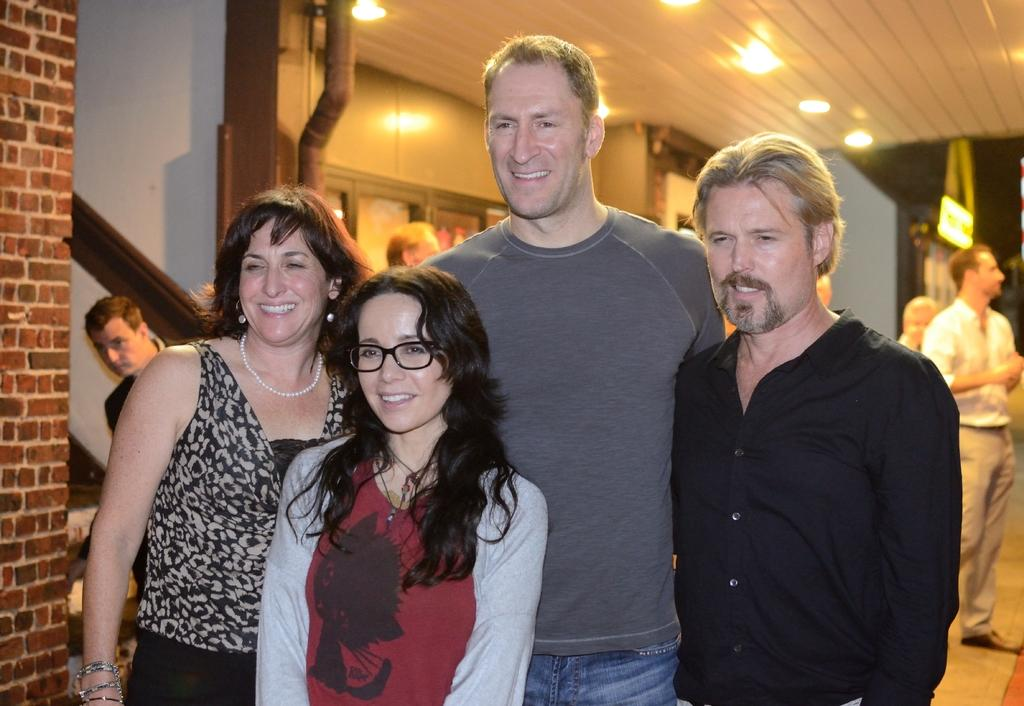What can be seen in the image involving people? There are people standing in the image. What type of structure is visible in the image? There is a wall visible in the image. What is on top of the wall in the image? The roof with lights is present in the image. What architectural feature can be seen in the image? There is a pole in the image. What allows light into the structure in the image? Windows are visible in the image. What is the surface beneath the people and structures in the image? The ground is visible in the image. What key is used to unlock the door in the image? There is no door or key present in the image; it only features people, a wall, a roof with lights, a pole, windows, and the ground. 